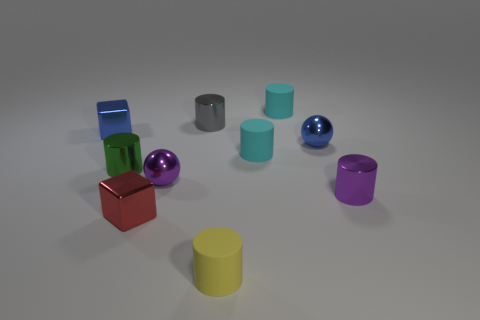What shape is the green object that is the same size as the red block?
Your answer should be very brief. Cylinder. Is there any other thing that has the same size as the green metallic object?
Your answer should be compact. Yes. What is the material of the sphere right of the small object behind the gray thing?
Ensure brevity in your answer.  Metal. Does the yellow object have the same size as the purple metal ball?
Your answer should be very brief. Yes. What number of objects are either tiny blue shiny things on the left side of the tiny purple metal sphere or purple shiny cubes?
Offer a very short reply. 1. There is a small blue metal thing to the left of the tiny blue shiny thing right of the tiny yellow thing; what shape is it?
Your answer should be compact. Cube. Does the yellow cylinder have the same size as the purple shiny object left of the purple metal cylinder?
Keep it short and to the point. Yes. What material is the thing in front of the red metal cube?
Your response must be concise. Rubber. What number of tiny shiny things are both in front of the tiny green object and to the right of the small yellow rubber object?
Provide a short and direct response. 1. There is a green cylinder that is the same size as the purple shiny cylinder; what material is it?
Offer a very short reply. Metal. 